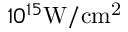Convert formula to latex. <formula><loc_0><loc_0><loc_500><loc_500>1 0 ^ { 1 5 } { W / c m ^ { 2 } }</formula> 